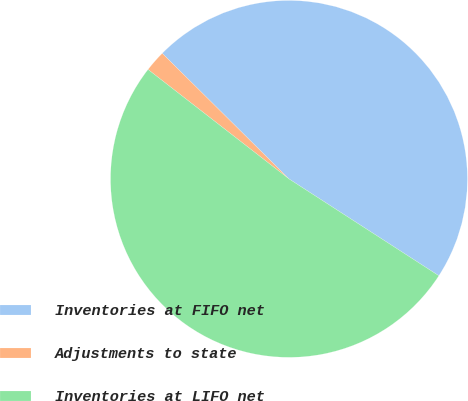Convert chart to OTSL. <chart><loc_0><loc_0><loc_500><loc_500><pie_chart><fcel>Inventories at FIFO net<fcel>Adjustments to state<fcel>Inventories at LIFO net<nl><fcel>46.7%<fcel>1.92%<fcel>51.37%<nl></chart> 